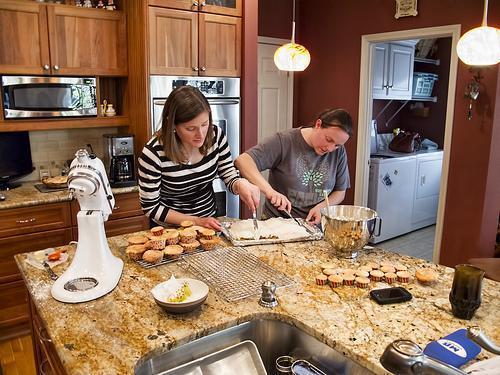How many people are in the kitchen?
Give a very brief answer. 2. 